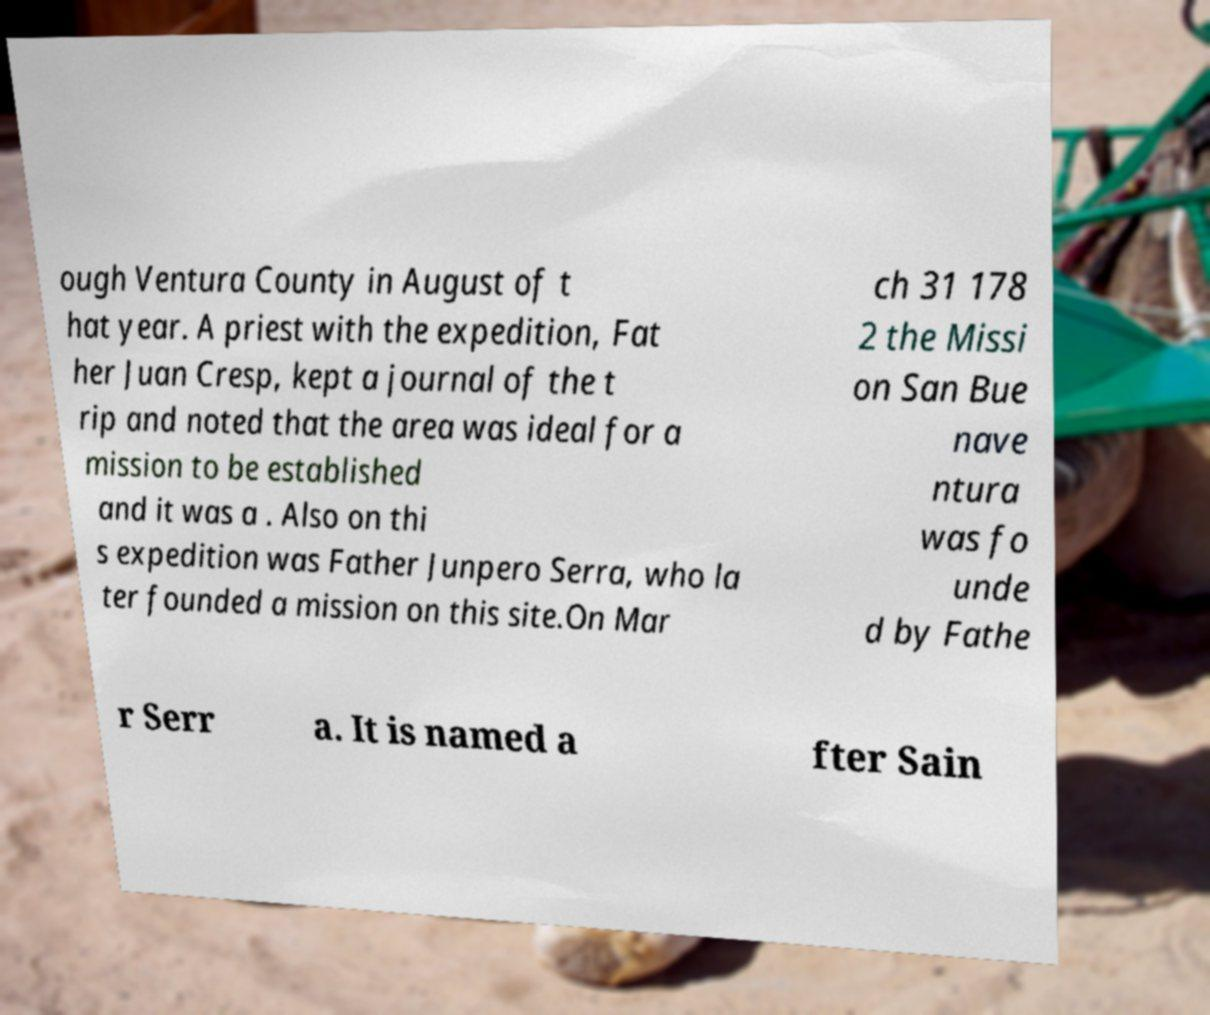What messages or text are displayed in this image? I need them in a readable, typed format. ough Ventura County in August of t hat year. A priest with the expedition, Fat her Juan Cresp, kept a journal of the t rip and noted that the area was ideal for a mission to be established and it was a . Also on thi s expedition was Father Junpero Serra, who la ter founded a mission on this site.On Mar ch 31 178 2 the Missi on San Bue nave ntura was fo unde d by Fathe r Serr a. It is named a fter Sain 